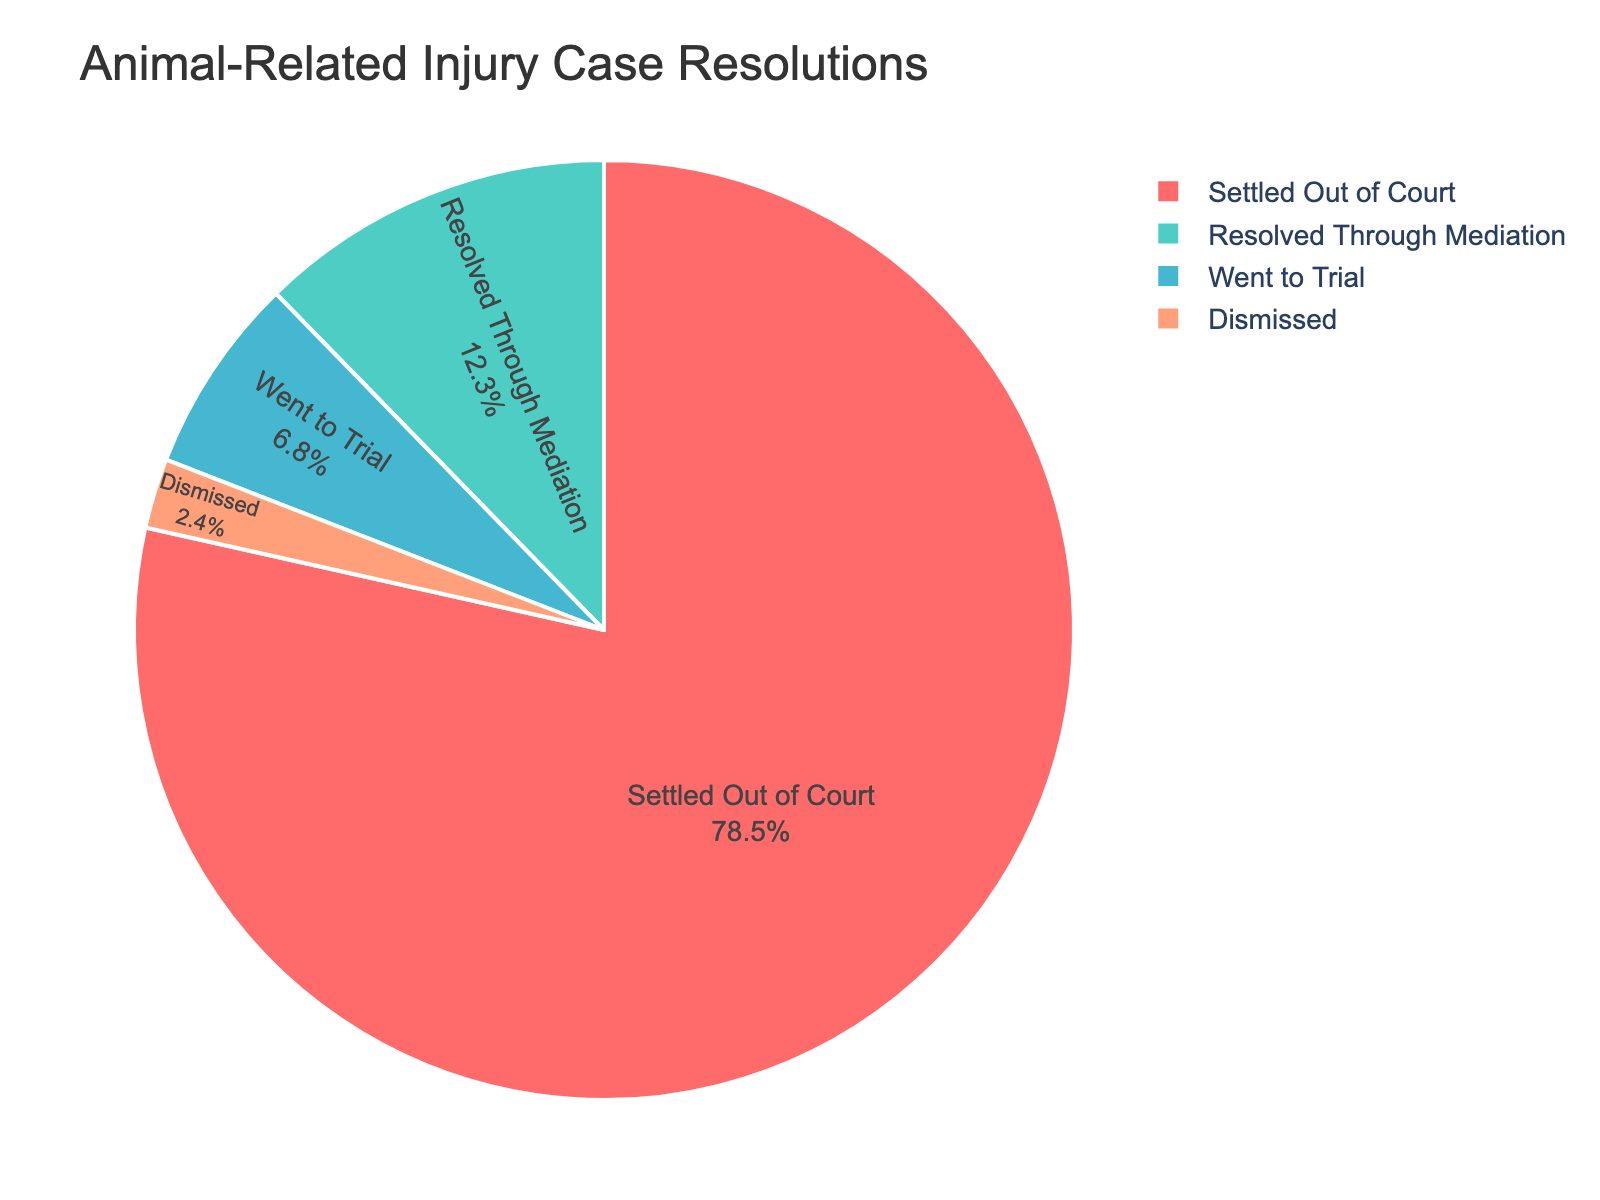What percentage of animal-related injury cases are settled out of court? The percentage of cases settled out of court can be directly read from the pie chart under the "Settled Out of Court" section.
Answer: 78.5% How many times more likely are cases to be settled out of court than to go to trial? To find this, divide the percentage of cases settled out of court by the percentage of cases that went to trial: 78.5 / 6.8.
Answer: 11.54 What is the combined percentage of cases that are either settled out of court or resolved through mediation? Add the percentage of cases settled out of court (78.5%) and the percentage resolved through mediation (12.3%) to get the combined percentage: 78.5 + 12.3.
Answer: 90.8% Which resolution method accounts for the smallest percentage of cases? The smallest percentage can be determined by finding the smallest value on the pie chart. In this case, it is 2.4% for cases that are dismissed.
Answer: Dismissed How does the percentage of cases that went to trial compare to those resolved through mediation? Compare the percentage of cases that went to trial (6.8%) with those resolved through mediation (12.3%). The cases resolved through mediation are greater.
Answer: Mediation cases are greater What is the total percentage of cases that are either dismissed or went to trial? Add the percentage of cases that are dismissed (2.4%) and the percentage that went to trial (6.8%): 2.4 + 6.8.
Answer: 9.2% Which resolution method is represented by the red segment in the pie chart? The red segment in the pie chart represents the "Settled Out of Court" category, as identified by the color palette and the chart legend.
Answer: Settled Out of Court What is the proportional difference between cases resolved through mediation and those dismissed? Subtract the percentage of cases dismissed from those resolved through mediation: 12.3 - 2.4.
Answer: 9.9% 